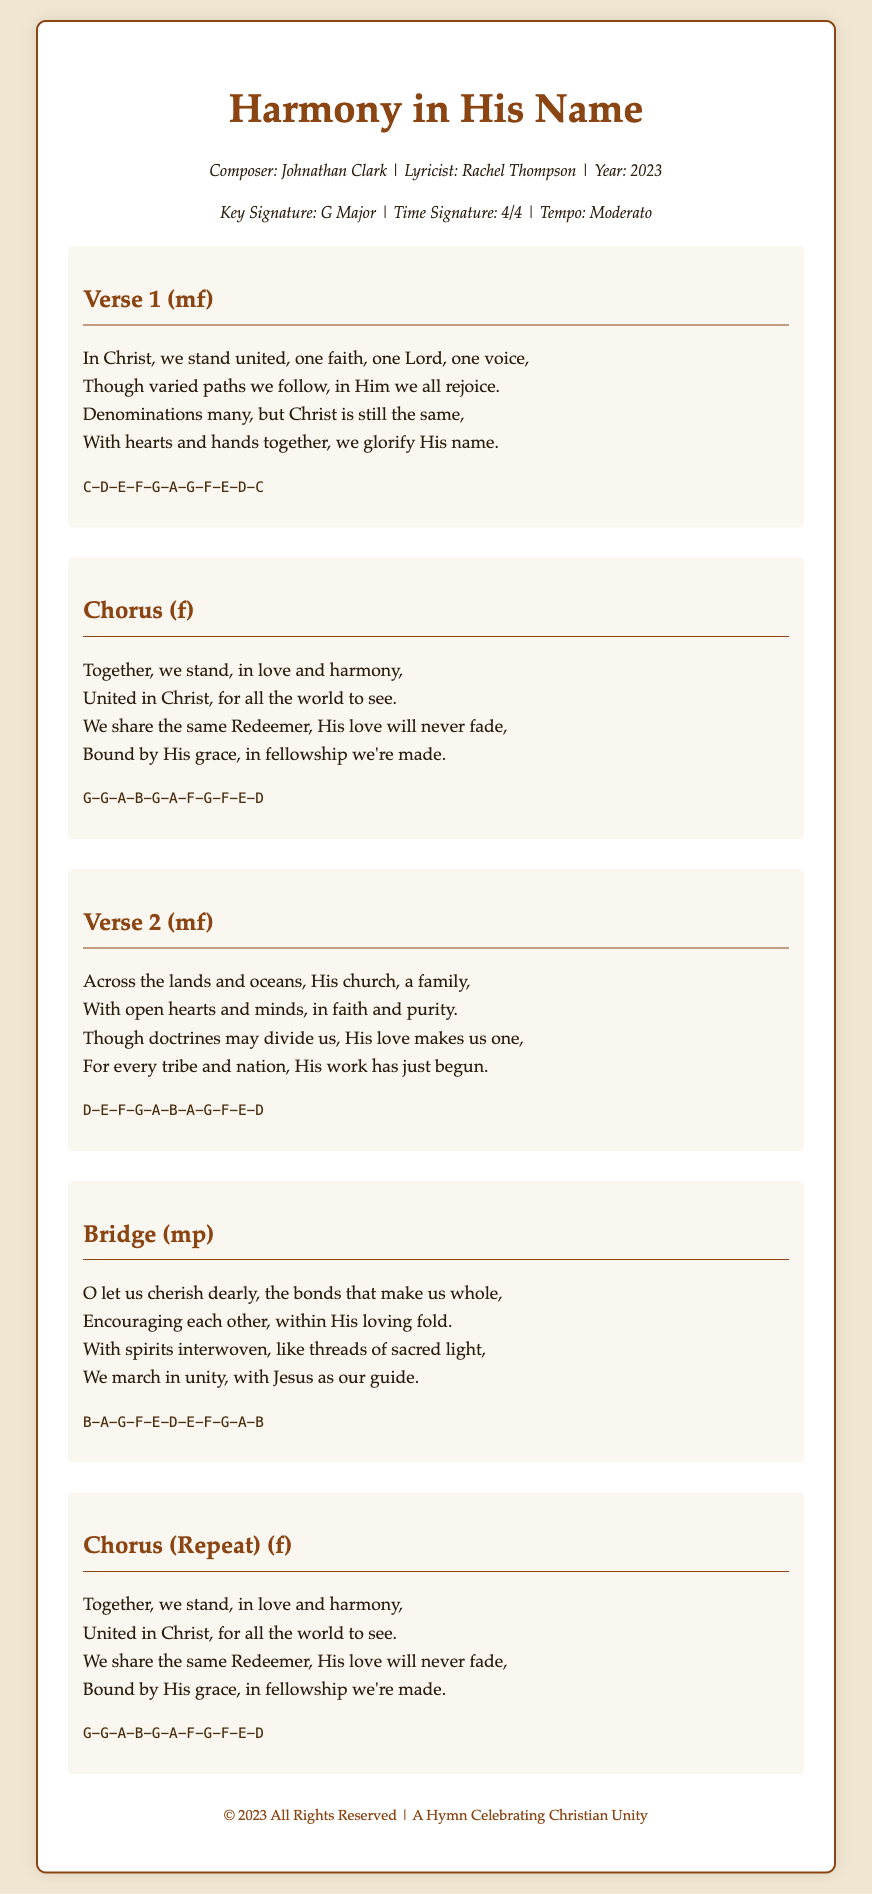What is the title of the hymn? The title is the main heading of the document, prominently displayed at the top.
Answer: Harmony in His Name Who is the composer of the hymn? The composer is mentioned in the metadata section under the title.
Answer: Johnathan Clark What year was the hymn composed? The year of composition is specified in the metadata section.
Answer: 2023 What is the key signature of the hymn? The key signature is indicated in the metadata section alongside other musical details.
Answer: G Major What is the time signature of the hymn? The time signature is given in the metadata section of the document.
Answer: 4/4 How many verses are present in the hymn? The document lists multiple sections, specifically indicating the verses.
Answer: 2 What does the first line of the chorus say? The chorus is a repeated section that follows a specific structure, starting with a unified declaration.
Answer: Together, we stand, in love and harmony, What musical notation is used for the bridge? The melody for each section includes a series of notes, specifically presented for the bridge.
Answer: B-A-G-F-E-D-E-F-G-A-B What is the dynamic marking for Verse 2? The dynamic marking is included with each section title to indicate the intended volume.
Answer: mf What unifying theme is reflected in the lyrics? The lyrics emphasize common faith and unity despite diversity in doctrines and traditions.
Answer: Unity and fellowship 